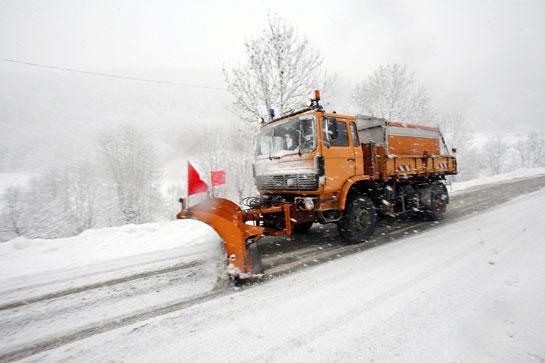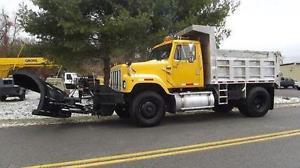The first image is the image on the left, the second image is the image on the right. For the images shown, is this caption "One image shows just one truck with a solid orange plow." true? Answer yes or no. Yes. 